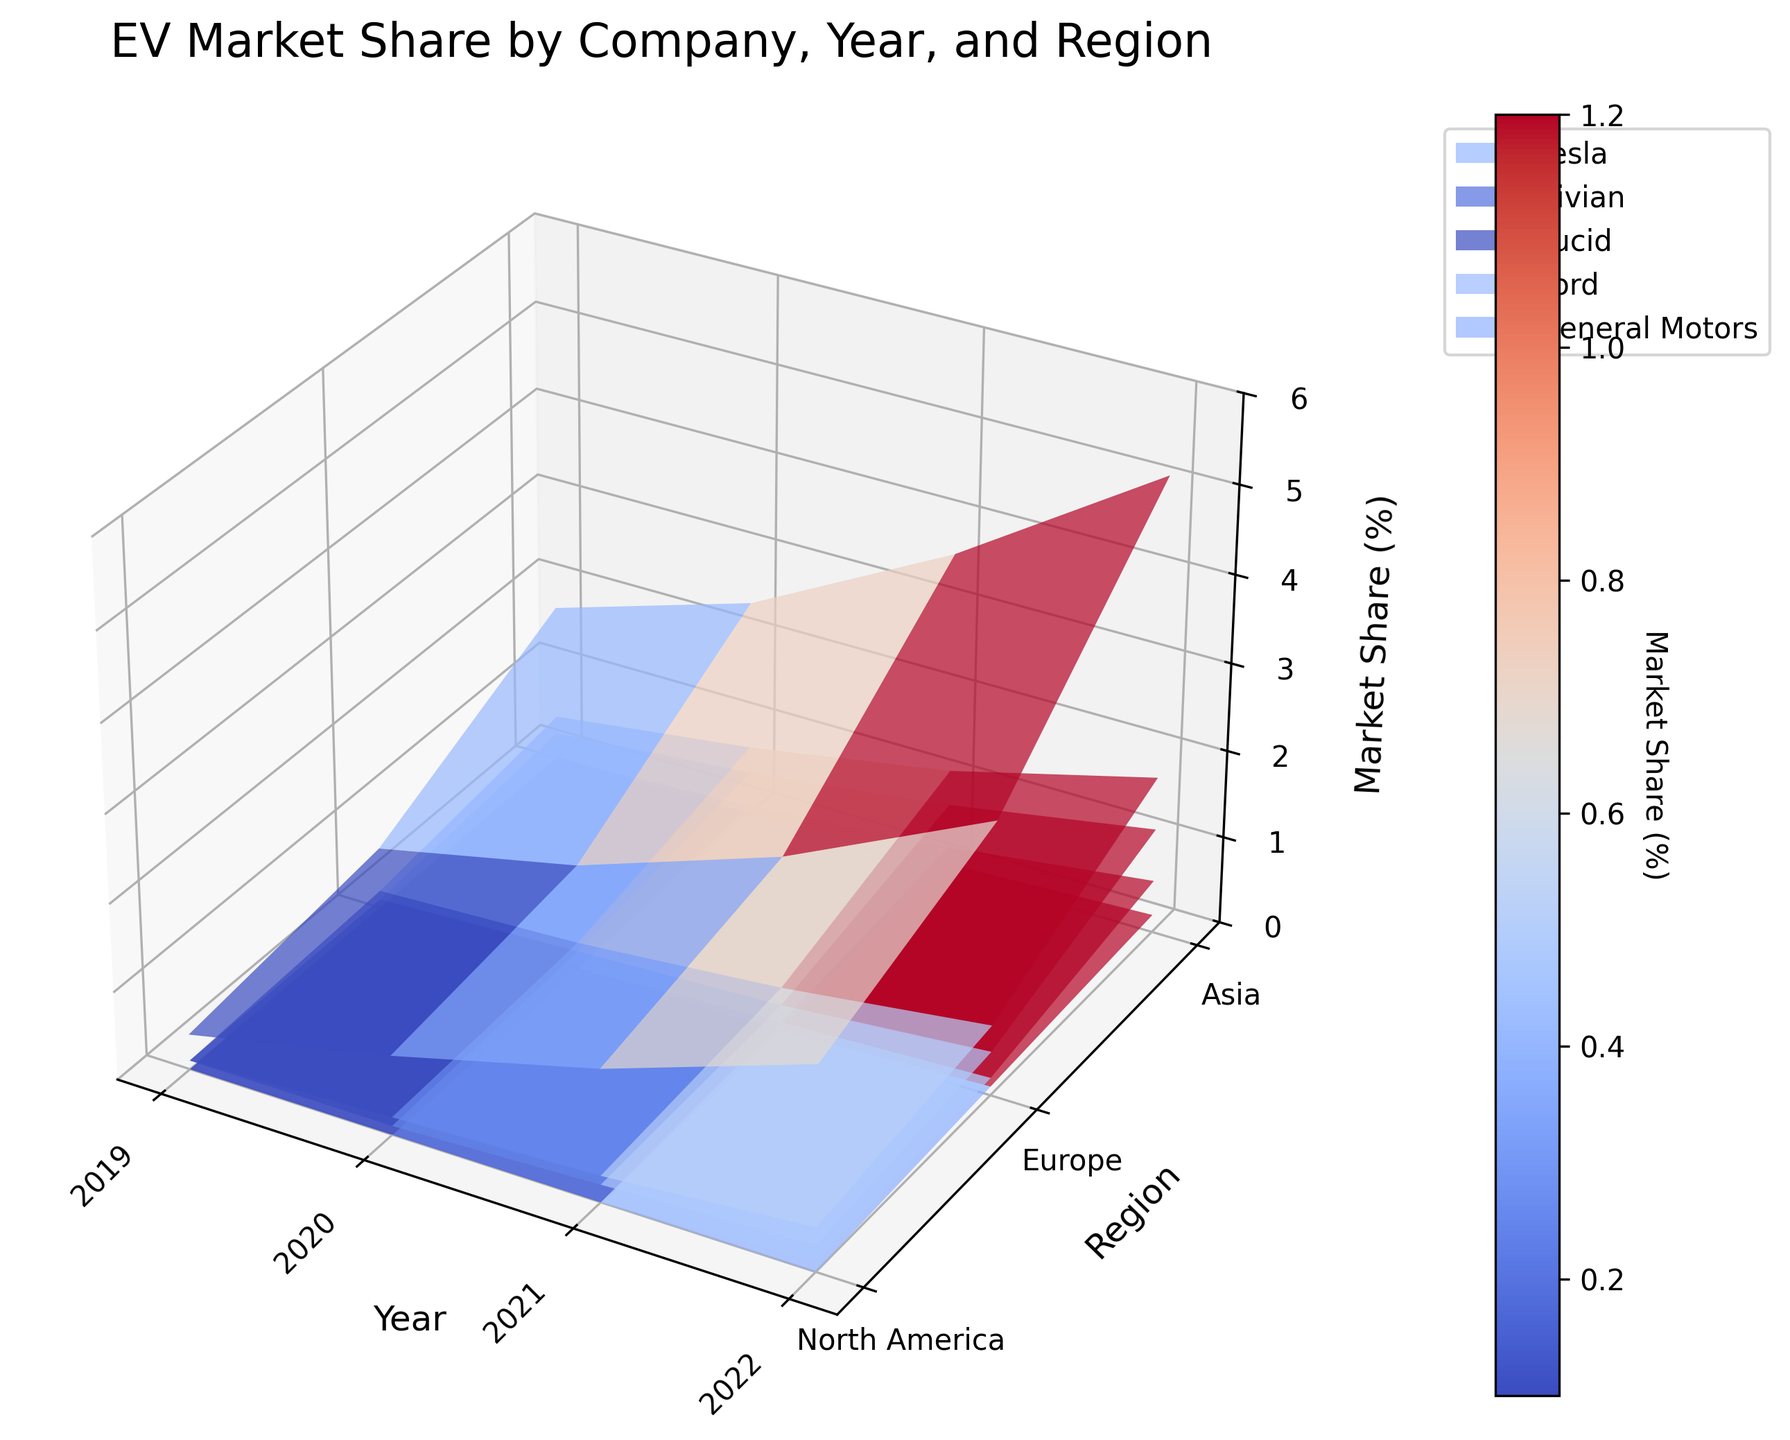What is the title of the plot? The plot's title is located at the top of the figure and provides an overview of the content displayed in the plot. The title of the plot is "EV Market Share by Company, Year, and Region."
Answer: EV Market Share by Company, Year, and Region Which company had the highest market share in North America in 2022? To find this, look at the section of the plot corresponding to North America in 2022 and identify the company with the highest surface peak. Tesla has the highest peak in this region and year.
Answer: Tesla What were the market shares for Ford and General Motors in Europe in 2020? Refer to the plot section for Europe in 2020 and note the heights of the surfaces for Ford and General Motors. Ford has a market share of 0.3%, and General Motors has a market share of 0.2%.
Answer: 0.3% for Ford, 0.2% for General Motors How did Tesla's market share change in Asia from 2019 to 2022? Observe the trajectory of Tesla's surface from 2019 to 2022 in the Asia section. In 2019 it was 0.4%, in 2020 it increased to 0.9%, further increasing to 1.5% in 2021, and finally reaching 2.3% in 2022.
Answer: Increased from 0.4% to 2.3% Compare the market share of Rivian in North America between 2020 and 2022. What trend do you notice? Compare the surface peaks for Rivian in North America for the years 2020 and 2022. The market share increases from 0.1% in 2020 to 0.6% in 2022, indicating growth.
Answer: Increased from 0.1% to 0.6% Which region saw the largest increase in market share for Tesla between 2019 and 2022? Examine the increase in Tesla's market share over the years in each region. North America saw an increase from 1.8% in 2019 to 5.2% in 2022, which is greater than the increase in Europe and Asia.
Answer: North America What is the trend for Lucid's market share across all regions from 2019 to 2022? Analyze the change in Lucid's surface over the years. In 2019 and 2020, Lucid has 0% share in all regions, then starts appearing in 2021 with a slight increase and continues with more growth in 2022.
Answer: Increasing Which region had the smallest market share for General Motors in 2021? Compare General Motors' surface in different regions for the year 2021. Asia has the smallest market share at 0.2%.
Answer: Asia What was the average market share of Tesla in Europe from 2019 to 2022? Compute the average of Tesla's market shares in Europe for the given years: (0.7 + 1.2 + 2.0 + 3.1)/4 = 1.75.
Answer: 1.75% How does Ford's market share in North America in 2021 compare to its share in Asia in the same year? Review the height of Ford's surface for North America and Asia in 2021. In North America, Ford's share is 1.2%, while in Asia, it is 0.3%. Ford's market share in North America is significantly higher.
Answer: North America: 1.2%, Asia: 0.3% 